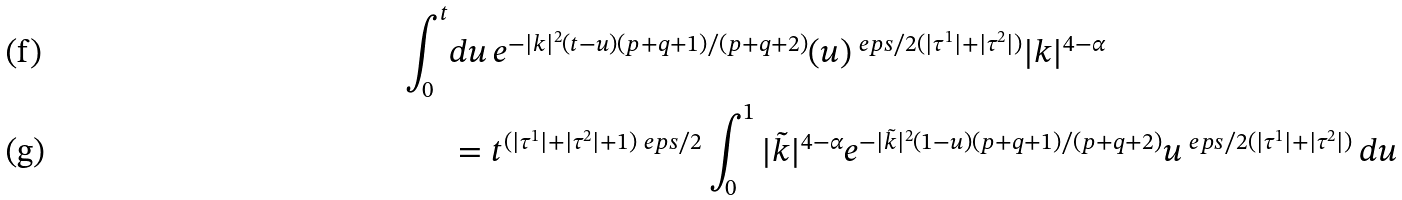<formula> <loc_0><loc_0><loc_500><loc_500>\int _ { 0 } ^ { t } & d u \, e ^ { - | k | ^ { 2 } ( t - u ) ( p + q + 1 ) / ( p + q + 2 ) } ( u ) ^ { \ e p s / 2 ( | \tau ^ { 1 } | + | \tau ^ { 2 } | ) } | k | ^ { 4 - \alpha } \\ & = t ^ { ( | \tau ^ { 1 } | + | \tau ^ { 2 } | + 1 ) \ e p s / 2 } \int _ { 0 } ^ { 1 } | \tilde { k } | ^ { 4 - \alpha } e ^ { - | \tilde { k } | ^ { 2 } ( 1 - u ) ( p + q + 1 ) / ( p + q + 2 ) } u ^ { \ e p s / 2 ( | \tau ^ { 1 } | + | \tau ^ { 2 } | ) } \, d u</formula> 